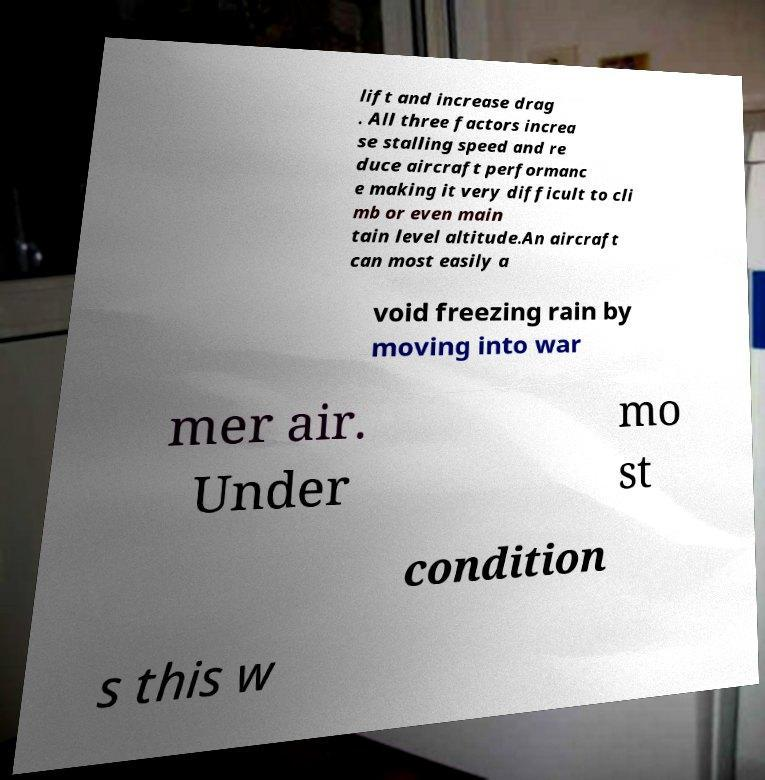Could you extract and type out the text from this image? lift and increase drag . All three factors increa se stalling speed and re duce aircraft performanc e making it very difficult to cli mb or even main tain level altitude.An aircraft can most easily a void freezing rain by moving into war mer air. Under mo st condition s this w 